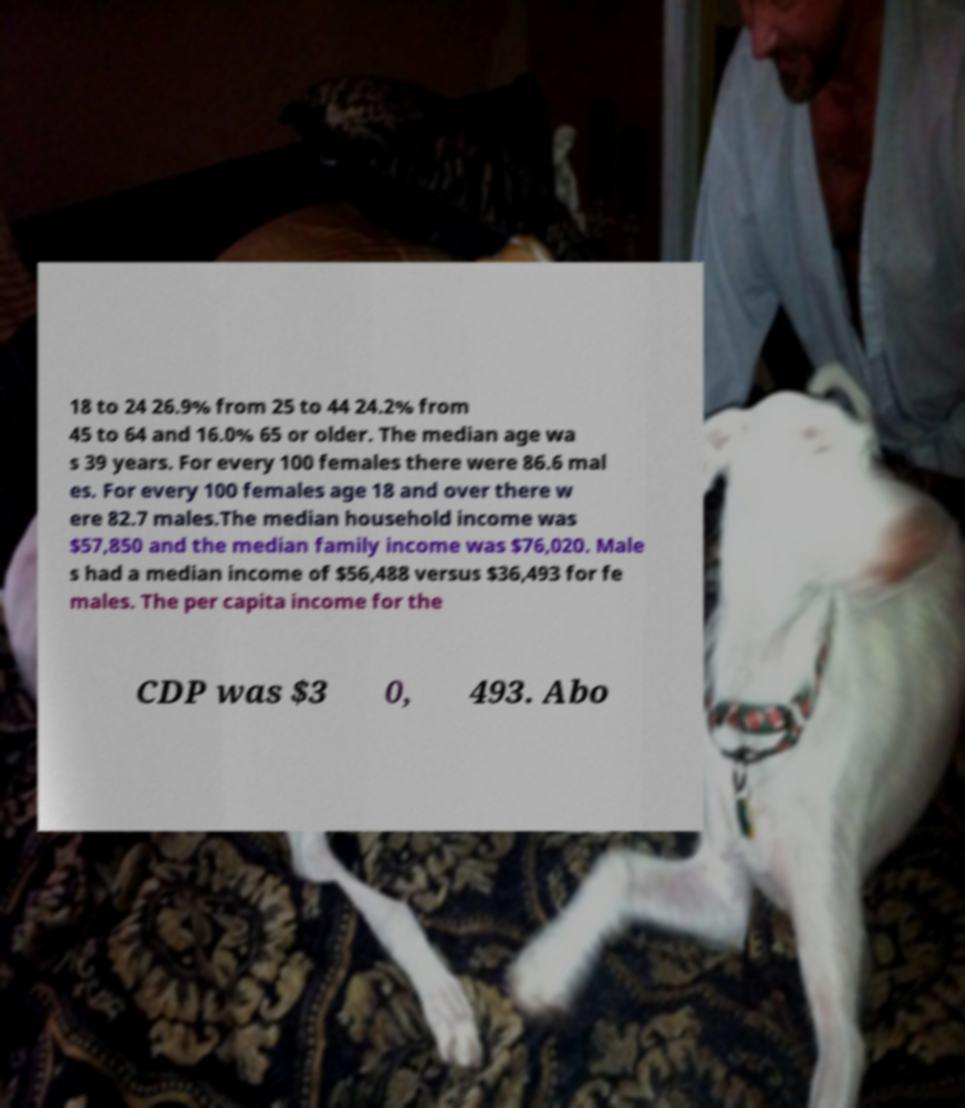Could you assist in decoding the text presented in this image and type it out clearly? 18 to 24 26.9% from 25 to 44 24.2% from 45 to 64 and 16.0% 65 or older. The median age wa s 39 years. For every 100 females there were 86.6 mal es. For every 100 females age 18 and over there w ere 82.7 males.The median household income was $57,850 and the median family income was $76,020. Male s had a median income of $56,488 versus $36,493 for fe males. The per capita income for the CDP was $3 0, 493. Abo 